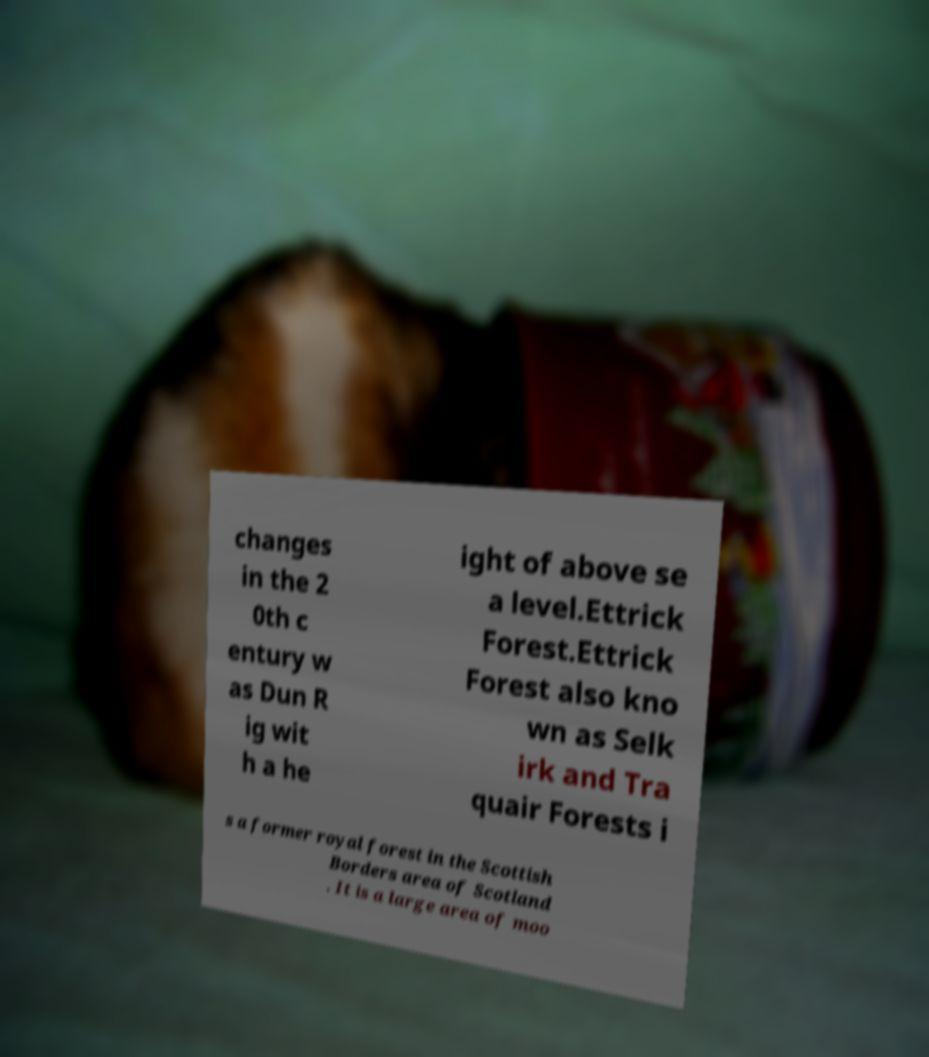Please read and relay the text visible in this image. What does it say? changes in the 2 0th c entury w as Dun R ig wit h a he ight of above se a level.Ettrick Forest.Ettrick Forest also kno wn as Selk irk and Tra quair Forests i s a former royal forest in the Scottish Borders area of Scotland . It is a large area of moo 